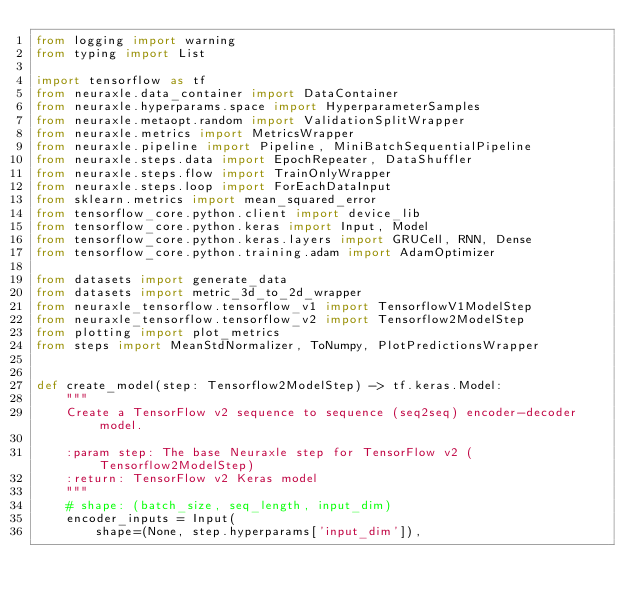<code> <loc_0><loc_0><loc_500><loc_500><_Python_>from logging import warning
from typing import List

import tensorflow as tf
from neuraxle.data_container import DataContainer
from neuraxle.hyperparams.space import HyperparameterSamples
from neuraxle.metaopt.random import ValidationSplitWrapper
from neuraxle.metrics import MetricsWrapper
from neuraxle.pipeline import Pipeline, MiniBatchSequentialPipeline
from neuraxle.steps.data import EpochRepeater, DataShuffler
from neuraxle.steps.flow import TrainOnlyWrapper
from neuraxle.steps.loop import ForEachDataInput
from sklearn.metrics import mean_squared_error
from tensorflow_core.python.client import device_lib
from tensorflow_core.python.keras import Input, Model
from tensorflow_core.python.keras.layers import GRUCell, RNN, Dense
from tensorflow_core.python.training.adam import AdamOptimizer

from datasets import generate_data
from datasets import metric_3d_to_2d_wrapper
from neuraxle_tensorflow.tensorflow_v1 import TensorflowV1ModelStep
from neuraxle_tensorflow.tensorflow_v2 import Tensorflow2ModelStep
from plotting import plot_metrics
from steps import MeanStdNormalizer, ToNumpy, PlotPredictionsWrapper


def create_model(step: Tensorflow2ModelStep) -> tf.keras.Model:
    """
    Create a TensorFlow v2 sequence to sequence (seq2seq) encoder-decoder model.

    :param step: The base Neuraxle step for TensorFlow v2 (Tensorflow2ModelStep)
    :return: TensorFlow v2 Keras model
    """
    # shape: (batch_size, seq_length, input_dim)
    encoder_inputs = Input(
        shape=(None, step.hyperparams['input_dim']),</code> 